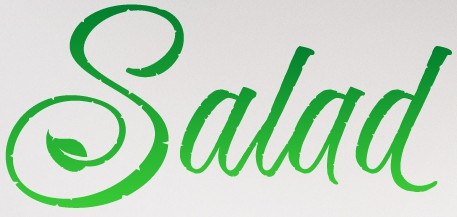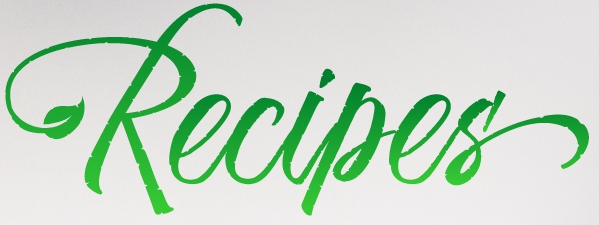What words are shown in these images in order, separated by a semicolon? Salad; Recipes' 